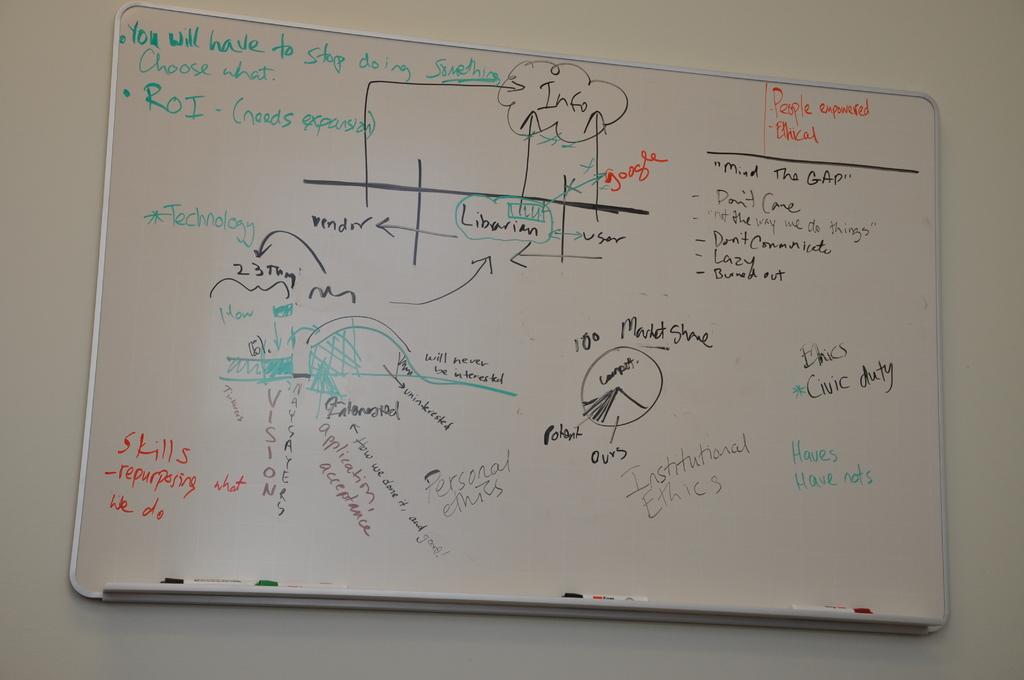What does it say about skills repurposing?
Ensure brevity in your answer.  What we do. What job title is listed in the middle of the board?
Ensure brevity in your answer.  Librarian. 